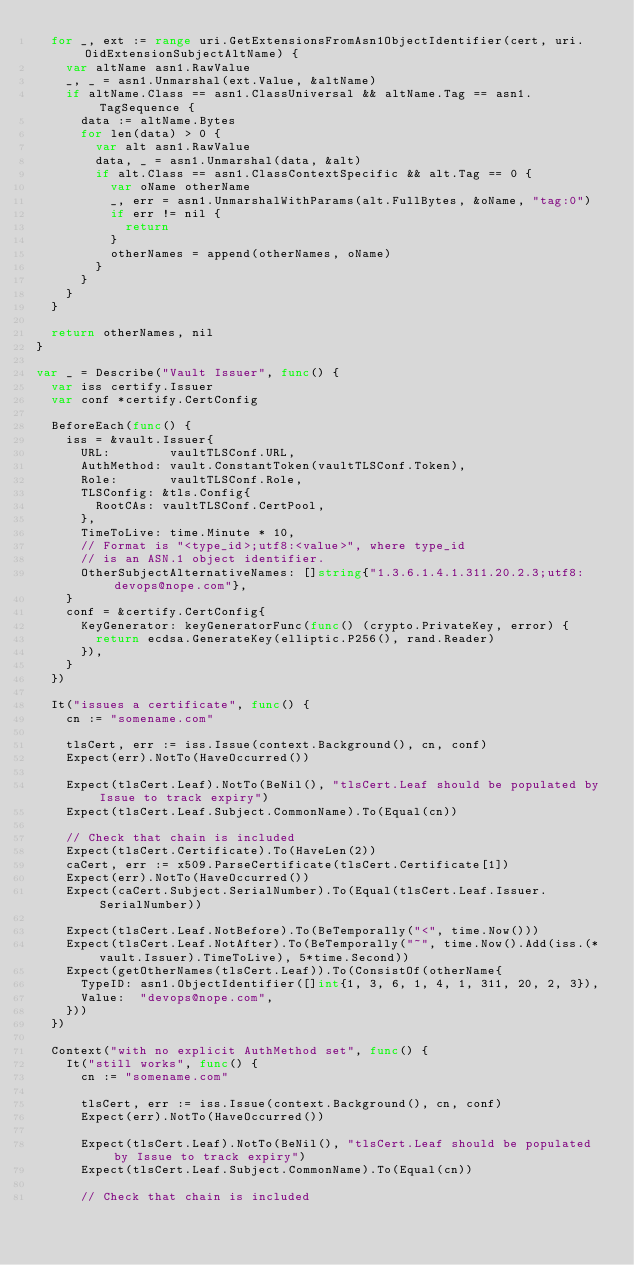Convert code to text. <code><loc_0><loc_0><loc_500><loc_500><_Go_>	for _, ext := range uri.GetExtensionsFromAsn1ObjectIdentifier(cert, uri.OidExtensionSubjectAltName) {
		var altName asn1.RawValue
		_, _ = asn1.Unmarshal(ext.Value, &altName)
		if altName.Class == asn1.ClassUniversal && altName.Tag == asn1.TagSequence {
			data := altName.Bytes
			for len(data) > 0 {
				var alt asn1.RawValue
				data, _ = asn1.Unmarshal(data, &alt)
				if alt.Class == asn1.ClassContextSpecific && alt.Tag == 0 {
					var oName otherName
					_, err = asn1.UnmarshalWithParams(alt.FullBytes, &oName, "tag:0")
					if err != nil {
						return
					}
					otherNames = append(otherNames, oName)
				}
			}
		}
	}

	return otherNames, nil
}

var _ = Describe("Vault Issuer", func() {
	var iss certify.Issuer
	var conf *certify.CertConfig

	BeforeEach(func() {
		iss = &vault.Issuer{
			URL:        vaultTLSConf.URL,
			AuthMethod: vault.ConstantToken(vaultTLSConf.Token),
			Role:       vaultTLSConf.Role,
			TLSConfig: &tls.Config{
				RootCAs: vaultTLSConf.CertPool,
			},
			TimeToLive: time.Minute * 10,
			// Format is "<type_id>;utf8:<value>", where type_id
			// is an ASN.1 object identifier.
			OtherSubjectAlternativeNames: []string{"1.3.6.1.4.1.311.20.2.3;utf8:devops@nope.com"},
		}
		conf = &certify.CertConfig{
			KeyGenerator: keyGeneratorFunc(func() (crypto.PrivateKey, error) {
				return ecdsa.GenerateKey(elliptic.P256(), rand.Reader)
			}),
		}
	})

	It("issues a certificate", func() {
		cn := "somename.com"

		tlsCert, err := iss.Issue(context.Background(), cn, conf)
		Expect(err).NotTo(HaveOccurred())

		Expect(tlsCert.Leaf).NotTo(BeNil(), "tlsCert.Leaf should be populated by Issue to track expiry")
		Expect(tlsCert.Leaf.Subject.CommonName).To(Equal(cn))

		// Check that chain is included
		Expect(tlsCert.Certificate).To(HaveLen(2))
		caCert, err := x509.ParseCertificate(tlsCert.Certificate[1])
		Expect(err).NotTo(HaveOccurred())
		Expect(caCert.Subject.SerialNumber).To(Equal(tlsCert.Leaf.Issuer.SerialNumber))

		Expect(tlsCert.Leaf.NotBefore).To(BeTemporally("<", time.Now()))
		Expect(tlsCert.Leaf.NotAfter).To(BeTemporally("~", time.Now().Add(iss.(*vault.Issuer).TimeToLive), 5*time.Second))
		Expect(getOtherNames(tlsCert.Leaf)).To(ConsistOf(otherName{
			TypeID: asn1.ObjectIdentifier([]int{1, 3, 6, 1, 4, 1, 311, 20, 2, 3}),
			Value:  "devops@nope.com",
		}))
	})

	Context("with no explicit AuthMethod set", func() {
		It("still works", func() {
			cn := "somename.com"

			tlsCert, err := iss.Issue(context.Background(), cn, conf)
			Expect(err).NotTo(HaveOccurred())

			Expect(tlsCert.Leaf).NotTo(BeNil(), "tlsCert.Leaf should be populated by Issue to track expiry")
			Expect(tlsCert.Leaf.Subject.CommonName).To(Equal(cn))

			// Check that chain is included</code> 